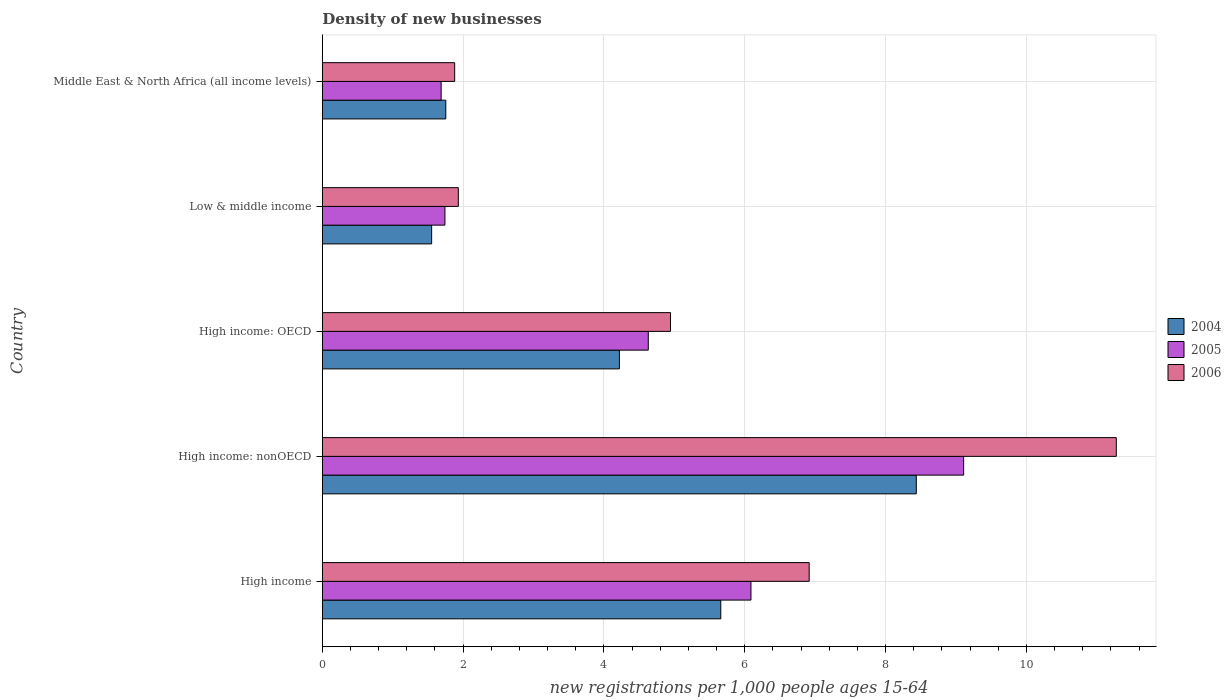How many different coloured bars are there?
Provide a short and direct response. 3. How many groups of bars are there?
Keep it short and to the point. 5. Are the number of bars per tick equal to the number of legend labels?
Your response must be concise. Yes. How many bars are there on the 1st tick from the bottom?
Your response must be concise. 3. What is the label of the 4th group of bars from the top?
Give a very brief answer. High income: nonOECD. In how many cases, is the number of bars for a given country not equal to the number of legend labels?
Keep it short and to the point. 0. What is the number of new registrations in 2005 in Low & middle income?
Make the answer very short. 1.74. Across all countries, what is the maximum number of new registrations in 2005?
Offer a terse response. 9.11. Across all countries, what is the minimum number of new registrations in 2005?
Provide a short and direct response. 1.69. In which country was the number of new registrations in 2005 maximum?
Keep it short and to the point. High income: nonOECD. In which country was the number of new registrations in 2005 minimum?
Provide a succinct answer. Middle East & North Africa (all income levels). What is the total number of new registrations in 2004 in the graph?
Offer a terse response. 21.62. What is the difference between the number of new registrations in 2005 in High income and that in High income: nonOECD?
Provide a succinct answer. -3.02. What is the difference between the number of new registrations in 2005 in Low & middle income and the number of new registrations in 2006 in Middle East & North Africa (all income levels)?
Provide a succinct answer. -0.14. What is the average number of new registrations in 2005 per country?
Offer a very short reply. 4.65. What is the difference between the number of new registrations in 2005 and number of new registrations in 2004 in Middle East & North Africa (all income levels)?
Keep it short and to the point. -0.07. What is the ratio of the number of new registrations in 2004 in High income to that in High income: nonOECD?
Ensure brevity in your answer.  0.67. Is the number of new registrations in 2005 in High income: nonOECD less than that in Low & middle income?
Make the answer very short. No. Is the difference between the number of new registrations in 2005 in Low & middle income and Middle East & North Africa (all income levels) greater than the difference between the number of new registrations in 2004 in Low & middle income and Middle East & North Africa (all income levels)?
Your response must be concise. Yes. What is the difference between the highest and the second highest number of new registrations in 2005?
Provide a succinct answer. 3.02. What is the difference between the highest and the lowest number of new registrations in 2004?
Keep it short and to the point. 6.88. In how many countries, is the number of new registrations in 2006 greater than the average number of new registrations in 2006 taken over all countries?
Offer a terse response. 2. Is the sum of the number of new registrations in 2005 in High income and Low & middle income greater than the maximum number of new registrations in 2006 across all countries?
Make the answer very short. No. What does the 3rd bar from the bottom in Middle East & North Africa (all income levels) represents?
Your response must be concise. 2006. Is it the case that in every country, the sum of the number of new registrations in 2006 and number of new registrations in 2004 is greater than the number of new registrations in 2005?
Give a very brief answer. Yes. What is the difference between two consecutive major ticks on the X-axis?
Provide a short and direct response. 2. Are the values on the major ticks of X-axis written in scientific E-notation?
Your response must be concise. No. Where does the legend appear in the graph?
Your response must be concise. Center right. How many legend labels are there?
Make the answer very short. 3. How are the legend labels stacked?
Ensure brevity in your answer.  Vertical. What is the title of the graph?
Ensure brevity in your answer.  Density of new businesses. Does "2012" appear as one of the legend labels in the graph?
Give a very brief answer. No. What is the label or title of the X-axis?
Your answer should be compact. New registrations per 1,0 people ages 15-64. What is the label or title of the Y-axis?
Provide a succinct answer. Country. What is the new registrations per 1,000 people ages 15-64 of 2004 in High income?
Make the answer very short. 5.66. What is the new registrations per 1,000 people ages 15-64 of 2005 in High income?
Offer a terse response. 6.09. What is the new registrations per 1,000 people ages 15-64 in 2006 in High income?
Provide a succinct answer. 6.91. What is the new registrations per 1,000 people ages 15-64 in 2004 in High income: nonOECD?
Offer a very short reply. 8.44. What is the new registrations per 1,000 people ages 15-64 of 2005 in High income: nonOECD?
Your response must be concise. 9.11. What is the new registrations per 1,000 people ages 15-64 of 2006 in High income: nonOECD?
Make the answer very short. 11.28. What is the new registrations per 1,000 people ages 15-64 in 2004 in High income: OECD?
Your answer should be very brief. 4.22. What is the new registrations per 1,000 people ages 15-64 of 2005 in High income: OECD?
Make the answer very short. 4.63. What is the new registrations per 1,000 people ages 15-64 of 2006 in High income: OECD?
Give a very brief answer. 4.94. What is the new registrations per 1,000 people ages 15-64 in 2004 in Low & middle income?
Give a very brief answer. 1.55. What is the new registrations per 1,000 people ages 15-64 in 2005 in Low & middle income?
Provide a succinct answer. 1.74. What is the new registrations per 1,000 people ages 15-64 in 2006 in Low & middle income?
Offer a very short reply. 1.93. What is the new registrations per 1,000 people ages 15-64 of 2004 in Middle East & North Africa (all income levels)?
Provide a succinct answer. 1.75. What is the new registrations per 1,000 people ages 15-64 in 2005 in Middle East & North Africa (all income levels)?
Make the answer very short. 1.69. What is the new registrations per 1,000 people ages 15-64 of 2006 in Middle East & North Africa (all income levels)?
Provide a short and direct response. 1.88. Across all countries, what is the maximum new registrations per 1,000 people ages 15-64 of 2004?
Your answer should be compact. 8.44. Across all countries, what is the maximum new registrations per 1,000 people ages 15-64 of 2005?
Provide a succinct answer. 9.11. Across all countries, what is the maximum new registrations per 1,000 people ages 15-64 in 2006?
Provide a succinct answer. 11.28. Across all countries, what is the minimum new registrations per 1,000 people ages 15-64 of 2004?
Your answer should be very brief. 1.55. Across all countries, what is the minimum new registrations per 1,000 people ages 15-64 in 2005?
Your response must be concise. 1.69. Across all countries, what is the minimum new registrations per 1,000 people ages 15-64 in 2006?
Give a very brief answer. 1.88. What is the total new registrations per 1,000 people ages 15-64 of 2004 in the graph?
Provide a short and direct response. 21.62. What is the total new registrations per 1,000 people ages 15-64 of 2005 in the graph?
Ensure brevity in your answer.  23.25. What is the total new registrations per 1,000 people ages 15-64 of 2006 in the graph?
Make the answer very short. 26.95. What is the difference between the new registrations per 1,000 people ages 15-64 of 2004 in High income and that in High income: nonOECD?
Provide a short and direct response. -2.78. What is the difference between the new registrations per 1,000 people ages 15-64 in 2005 in High income and that in High income: nonOECD?
Offer a very short reply. -3.02. What is the difference between the new registrations per 1,000 people ages 15-64 in 2006 in High income and that in High income: nonOECD?
Keep it short and to the point. -4.36. What is the difference between the new registrations per 1,000 people ages 15-64 in 2004 in High income and that in High income: OECD?
Offer a very short reply. 1.44. What is the difference between the new registrations per 1,000 people ages 15-64 of 2005 in High income and that in High income: OECD?
Your answer should be very brief. 1.46. What is the difference between the new registrations per 1,000 people ages 15-64 in 2006 in High income and that in High income: OECD?
Offer a terse response. 1.97. What is the difference between the new registrations per 1,000 people ages 15-64 in 2004 in High income and that in Low & middle income?
Your response must be concise. 4.11. What is the difference between the new registrations per 1,000 people ages 15-64 in 2005 in High income and that in Low & middle income?
Provide a short and direct response. 4.35. What is the difference between the new registrations per 1,000 people ages 15-64 in 2006 in High income and that in Low & middle income?
Offer a very short reply. 4.98. What is the difference between the new registrations per 1,000 people ages 15-64 in 2004 in High income and that in Middle East & North Africa (all income levels)?
Give a very brief answer. 3.91. What is the difference between the new registrations per 1,000 people ages 15-64 in 2005 in High income and that in Middle East & North Africa (all income levels)?
Keep it short and to the point. 4.4. What is the difference between the new registrations per 1,000 people ages 15-64 in 2006 in High income and that in Middle East & North Africa (all income levels)?
Provide a succinct answer. 5.04. What is the difference between the new registrations per 1,000 people ages 15-64 in 2004 in High income: nonOECD and that in High income: OECD?
Provide a short and direct response. 4.22. What is the difference between the new registrations per 1,000 people ages 15-64 of 2005 in High income: nonOECD and that in High income: OECD?
Ensure brevity in your answer.  4.48. What is the difference between the new registrations per 1,000 people ages 15-64 in 2006 in High income: nonOECD and that in High income: OECD?
Ensure brevity in your answer.  6.33. What is the difference between the new registrations per 1,000 people ages 15-64 of 2004 in High income: nonOECD and that in Low & middle income?
Offer a terse response. 6.88. What is the difference between the new registrations per 1,000 people ages 15-64 in 2005 in High income: nonOECD and that in Low & middle income?
Your answer should be very brief. 7.37. What is the difference between the new registrations per 1,000 people ages 15-64 in 2006 in High income: nonOECD and that in Low & middle income?
Your response must be concise. 9.34. What is the difference between the new registrations per 1,000 people ages 15-64 of 2004 in High income: nonOECD and that in Middle East & North Africa (all income levels)?
Keep it short and to the point. 6.68. What is the difference between the new registrations per 1,000 people ages 15-64 in 2005 in High income: nonOECD and that in Middle East & North Africa (all income levels)?
Your response must be concise. 7.42. What is the difference between the new registrations per 1,000 people ages 15-64 of 2006 in High income: nonOECD and that in Middle East & North Africa (all income levels)?
Your response must be concise. 9.4. What is the difference between the new registrations per 1,000 people ages 15-64 of 2004 in High income: OECD and that in Low & middle income?
Provide a short and direct response. 2.67. What is the difference between the new registrations per 1,000 people ages 15-64 in 2005 in High income: OECD and that in Low & middle income?
Keep it short and to the point. 2.89. What is the difference between the new registrations per 1,000 people ages 15-64 of 2006 in High income: OECD and that in Low & middle income?
Your answer should be compact. 3.01. What is the difference between the new registrations per 1,000 people ages 15-64 of 2004 in High income: OECD and that in Middle East & North Africa (all income levels)?
Provide a succinct answer. 2.47. What is the difference between the new registrations per 1,000 people ages 15-64 in 2005 in High income: OECD and that in Middle East & North Africa (all income levels)?
Offer a terse response. 2.94. What is the difference between the new registrations per 1,000 people ages 15-64 of 2006 in High income: OECD and that in Middle East & North Africa (all income levels)?
Provide a succinct answer. 3.07. What is the difference between the new registrations per 1,000 people ages 15-64 in 2004 in Low & middle income and that in Middle East & North Africa (all income levels)?
Your answer should be compact. -0.2. What is the difference between the new registrations per 1,000 people ages 15-64 in 2005 in Low & middle income and that in Middle East & North Africa (all income levels)?
Offer a terse response. 0.05. What is the difference between the new registrations per 1,000 people ages 15-64 of 2006 in Low & middle income and that in Middle East & North Africa (all income levels)?
Your response must be concise. 0.05. What is the difference between the new registrations per 1,000 people ages 15-64 in 2004 in High income and the new registrations per 1,000 people ages 15-64 in 2005 in High income: nonOECD?
Your response must be concise. -3.45. What is the difference between the new registrations per 1,000 people ages 15-64 of 2004 in High income and the new registrations per 1,000 people ages 15-64 of 2006 in High income: nonOECD?
Provide a succinct answer. -5.62. What is the difference between the new registrations per 1,000 people ages 15-64 in 2005 in High income and the new registrations per 1,000 people ages 15-64 in 2006 in High income: nonOECD?
Your response must be concise. -5.19. What is the difference between the new registrations per 1,000 people ages 15-64 in 2004 in High income and the new registrations per 1,000 people ages 15-64 in 2005 in High income: OECD?
Your response must be concise. 1.03. What is the difference between the new registrations per 1,000 people ages 15-64 of 2004 in High income and the new registrations per 1,000 people ages 15-64 of 2006 in High income: OECD?
Provide a short and direct response. 0.71. What is the difference between the new registrations per 1,000 people ages 15-64 of 2005 in High income and the new registrations per 1,000 people ages 15-64 of 2006 in High income: OECD?
Provide a short and direct response. 1.14. What is the difference between the new registrations per 1,000 people ages 15-64 in 2004 in High income and the new registrations per 1,000 people ages 15-64 in 2005 in Low & middle income?
Provide a short and direct response. 3.92. What is the difference between the new registrations per 1,000 people ages 15-64 of 2004 in High income and the new registrations per 1,000 people ages 15-64 of 2006 in Low & middle income?
Ensure brevity in your answer.  3.73. What is the difference between the new registrations per 1,000 people ages 15-64 of 2005 in High income and the new registrations per 1,000 people ages 15-64 of 2006 in Low & middle income?
Your answer should be compact. 4.16. What is the difference between the new registrations per 1,000 people ages 15-64 in 2004 in High income and the new registrations per 1,000 people ages 15-64 in 2005 in Middle East & North Africa (all income levels)?
Make the answer very short. 3.97. What is the difference between the new registrations per 1,000 people ages 15-64 in 2004 in High income and the new registrations per 1,000 people ages 15-64 in 2006 in Middle East & North Africa (all income levels)?
Your response must be concise. 3.78. What is the difference between the new registrations per 1,000 people ages 15-64 in 2005 in High income and the new registrations per 1,000 people ages 15-64 in 2006 in Middle East & North Africa (all income levels)?
Your answer should be very brief. 4.21. What is the difference between the new registrations per 1,000 people ages 15-64 of 2004 in High income: nonOECD and the new registrations per 1,000 people ages 15-64 of 2005 in High income: OECD?
Ensure brevity in your answer.  3.81. What is the difference between the new registrations per 1,000 people ages 15-64 in 2004 in High income: nonOECD and the new registrations per 1,000 people ages 15-64 in 2006 in High income: OECD?
Keep it short and to the point. 3.49. What is the difference between the new registrations per 1,000 people ages 15-64 in 2005 in High income: nonOECD and the new registrations per 1,000 people ages 15-64 in 2006 in High income: OECD?
Ensure brevity in your answer.  4.16. What is the difference between the new registrations per 1,000 people ages 15-64 in 2004 in High income: nonOECD and the new registrations per 1,000 people ages 15-64 in 2005 in Low & middle income?
Provide a succinct answer. 6.69. What is the difference between the new registrations per 1,000 people ages 15-64 in 2004 in High income: nonOECD and the new registrations per 1,000 people ages 15-64 in 2006 in Low & middle income?
Ensure brevity in your answer.  6.5. What is the difference between the new registrations per 1,000 people ages 15-64 in 2005 in High income: nonOECD and the new registrations per 1,000 people ages 15-64 in 2006 in Low & middle income?
Give a very brief answer. 7.18. What is the difference between the new registrations per 1,000 people ages 15-64 in 2004 in High income: nonOECD and the new registrations per 1,000 people ages 15-64 in 2005 in Middle East & North Africa (all income levels)?
Offer a terse response. 6.75. What is the difference between the new registrations per 1,000 people ages 15-64 in 2004 in High income: nonOECD and the new registrations per 1,000 people ages 15-64 in 2006 in Middle East & North Africa (all income levels)?
Offer a very short reply. 6.56. What is the difference between the new registrations per 1,000 people ages 15-64 of 2005 in High income: nonOECD and the new registrations per 1,000 people ages 15-64 of 2006 in Middle East & North Africa (all income levels)?
Ensure brevity in your answer.  7.23. What is the difference between the new registrations per 1,000 people ages 15-64 of 2004 in High income: OECD and the new registrations per 1,000 people ages 15-64 of 2005 in Low & middle income?
Provide a succinct answer. 2.48. What is the difference between the new registrations per 1,000 people ages 15-64 in 2004 in High income: OECD and the new registrations per 1,000 people ages 15-64 in 2006 in Low & middle income?
Your response must be concise. 2.29. What is the difference between the new registrations per 1,000 people ages 15-64 in 2005 in High income: OECD and the new registrations per 1,000 people ages 15-64 in 2006 in Low & middle income?
Provide a short and direct response. 2.7. What is the difference between the new registrations per 1,000 people ages 15-64 of 2004 in High income: OECD and the new registrations per 1,000 people ages 15-64 of 2005 in Middle East & North Africa (all income levels)?
Ensure brevity in your answer.  2.53. What is the difference between the new registrations per 1,000 people ages 15-64 in 2004 in High income: OECD and the new registrations per 1,000 people ages 15-64 in 2006 in Middle East & North Africa (all income levels)?
Keep it short and to the point. 2.34. What is the difference between the new registrations per 1,000 people ages 15-64 of 2005 in High income: OECD and the new registrations per 1,000 people ages 15-64 of 2006 in Middle East & North Africa (all income levels)?
Provide a succinct answer. 2.75. What is the difference between the new registrations per 1,000 people ages 15-64 in 2004 in Low & middle income and the new registrations per 1,000 people ages 15-64 in 2005 in Middle East & North Africa (all income levels)?
Provide a short and direct response. -0.13. What is the difference between the new registrations per 1,000 people ages 15-64 in 2004 in Low & middle income and the new registrations per 1,000 people ages 15-64 in 2006 in Middle East & North Africa (all income levels)?
Give a very brief answer. -0.33. What is the difference between the new registrations per 1,000 people ages 15-64 of 2005 in Low & middle income and the new registrations per 1,000 people ages 15-64 of 2006 in Middle East & North Africa (all income levels)?
Make the answer very short. -0.14. What is the average new registrations per 1,000 people ages 15-64 of 2004 per country?
Ensure brevity in your answer.  4.32. What is the average new registrations per 1,000 people ages 15-64 of 2005 per country?
Your answer should be compact. 4.65. What is the average new registrations per 1,000 people ages 15-64 in 2006 per country?
Provide a succinct answer. 5.39. What is the difference between the new registrations per 1,000 people ages 15-64 of 2004 and new registrations per 1,000 people ages 15-64 of 2005 in High income?
Make the answer very short. -0.43. What is the difference between the new registrations per 1,000 people ages 15-64 in 2004 and new registrations per 1,000 people ages 15-64 in 2006 in High income?
Your response must be concise. -1.26. What is the difference between the new registrations per 1,000 people ages 15-64 of 2005 and new registrations per 1,000 people ages 15-64 of 2006 in High income?
Give a very brief answer. -0.83. What is the difference between the new registrations per 1,000 people ages 15-64 of 2004 and new registrations per 1,000 people ages 15-64 of 2005 in High income: nonOECD?
Provide a succinct answer. -0.67. What is the difference between the new registrations per 1,000 people ages 15-64 in 2004 and new registrations per 1,000 people ages 15-64 in 2006 in High income: nonOECD?
Offer a terse response. -2.84. What is the difference between the new registrations per 1,000 people ages 15-64 in 2005 and new registrations per 1,000 people ages 15-64 in 2006 in High income: nonOECD?
Keep it short and to the point. -2.17. What is the difference between the new registrations per 1,000 people ages 15-64 in 2004 and new registrations per 1,000 people ages 15-64 in 2005 in High income: OECD?
Your answer should be compact. -0.41. What is the difference between the new registrations per 1,000 people ages 15-64 in 2004 and new registrations per 1,000 people ages 15-64 in 2006 in High income: OECD?
Your response must be concise. -0.73. What is the difference between the new registrations per 1,000 people ages 15-64 in 2005 and new registrations per 1,000 people ages 15-64 in 2006 in High income: OECD?
Offer a terse response. -0.32. What is the difference between the new registrations per 1,000 people ages 15-64 in 2004 and new registrations per 1,000 people ages 15-64 in 2005 in Low & middle income?
Offer a terse response. -0.19. What is the difference between the new registrations per 1,000 people ages 15-64 of 2004 and new registrations per 1,000 people ages 15-64 of 2006 in Low & middle income?
Offer a terse response. -0.38. What is the difference between the new registrations per 1,000 people ages 15-64 in 2005 and new registrations per 1,000 people ages 15-64 in 2006 in Low & middle income?
Your response must be concise. -0.19. What is the difference between the new registrations per 1,000 people ages 15-64 in 2004 and new registrations per 1,000 people ages 15-64 in 2005 in Middle East & North Africa (all income levels)?
Give a very brief answer. 0.07. What is the difference between the new registrations per 1,000 people ages 15-64 in 2004 and new registrations per 1,000 people ages 15-64 in 2006 in Middle East & North Africa (all income levels)?
Keep it short and to the point. -0.13. What is the difference between the new registrations per 1,000 people ages 15-64 of 2005 and new registrations per 1,000 people ages 15-64 of 2006 in Middle East & North Africa (all income levels)?
Give a very brief answer. -0.19. What is the ratio of the new registrations per 1,000 people ages 15-64 in 2004 in High income to that in High income: nonOECD?
Provide a short and direct response. 0.67. What is the ratio of the new registrations per 1,000 people ages 15-64 of 2005 in High income to that in High income: nonOECD?
Your answer should be very brief. 0.67. What is the ratio of the new registrations per 1,000 people ages 15-64 in 2006 in High income to that in High income: nonOECD?
Provide a short and direct response. 0.61. What is the ratio of the new registrations per 1,000 people ages 15-64 in 2004 in High income to that in High income: OECD?
Provide a succinct answer. 1.34. What is the ratio of the new registrations per 1,000 people ages 15-64 in 2005 in High income to that in High income: OECD?
Provide a succinct answer. 1.31. What is the ratio of the new registrations per 1,000 people ages 15-64 in 2006 in High income to that in High income: OECD?
Keep it short and to the point. 1.4. What is the ratio of the new registrations per 1,000 people ages 15-64 in 2004 in High income to that in Low & middle income?
Give a very brief answer. 3.64. What is the ratio of the new registrations per 1,000 people ages 15-64 of 2005 in High income to that in Low & middle income?
Make the answer very short. 3.5. What is the ratio of the new registrations per 1,000 people ages 15-64 of 2006 in High income to that in Low & middle income?
Ensure brevity in your answer.  3.58. What is the ratio of the new registrations per 1,000 people ages 15-64 in 2004 in High income to that in Middle East & North Africa (all income levels)?
Your answer should be very brief. 3.23. What is the ratio of the new registrations per 1,000 people ages 15-64 in 2005 in High income to that in Middle East & North Africa (all income levels)?
Your answer should be very brief. 3.61. What is the ratio of the new registrations per 1,000 people ages 15-64 of 2006 in High income to that in Middle East & North Africa (all income levels)?
Ensure brevity in your answer.  3.68. What is the ratio of the new registrations per 1,000 people ages 15-64 of 2004 in High income: nonOECD to that in High income: OECD?
Offer a terse response. 2. What is the ratio of the new registrations per 1,000 people ages 15-64 in 2005 in High income: nonOECD to that in High income: OECD?
Your answer should be very brief. 1.97. What is the ratio of the new registrations per 1,000 people ages 15-64 in 2006 in High income: nonOECD to that in High income: OECD?
Provide a succinct answer. 2.28. What is the ratio of the new registrations per 1,000 people ages 15-64 of 2004 in High income: nonOECD to that in Low & middle income?
Make the answer very short. 5.43. What is the ratio of the new registrations per 1,000 people ages 15-64 of 2005 in High income: nonOECD to that in Low & middle income?
Keep it short and to the point. 5.23. What is the ratio of the new registrations per 1,000 people ages 15-64 of 2006 in High income: nonOECD to that in Low & middle income?
Your answer should be compact. 5.84. What is the ratio of the new registrations per 1,000 people ages 15-64 in 2004 in High income: nonOECD to that in Middle East & North Africa (all income levels)?
Keep it short and to the point. 4.81. What is the ratio of the new registrations per 1,000 people ages 15-64 of 2005 in High income: nonOECD to that in Middle East & North Africa (all income levels)?
Your response must be concise. 5.4. What is the ratio of the new registrations per 1,000 people ages 15-64 in 2006 in High income: nonOECD to that in Middle East & North Africa (all income levels)?
Your answer should be compact. 6. What is the ratio of the new registrations per 1,000 people ages 15-64 in 2004 in High income: OECD to that in Low & middle income?
Ensure brevity in your answer.  2.72. What is the ratio of the new registrations per 1,000 people ages 15-64 in 2005 in High income: OECD to that in Low & middle income?
Ensure brevity in your answer.  2.66. What is the ratio of the new registrations per 1,000 people ages 15-64 in 2006 in High income: OECD to that in Low & middle income?
Your answer should be very brief. 2.56. What is the ratio of the new registrations per 1,000 people ages 15-64 of 2004 in High income: OECD to that in Middle East & North Africa (all income levels)?
Offer a terse response. 2.41. What is the ratio of the new registrations per 1,000 people ages 15-64 of 2005 in High income: OECD to that in Middle East & North Africa (all income levels)?
Make the answer very short. 2.74. What is the ratio of the new registrations per 1,000 people ages 15-64 in 2006 in High income: OECD to that in Middle East & North Africa (all income levels)?
Provide a short and direct response. 2.63. What is the ratio of the new registrations per 1,000 people ages 15-64 in 2004 in Low & middle income to that in Middle East & North Africa (all income levels)?
Your response must be concise. 0.89. What is the ratio of the new registrations per 1,000 people ages 15-64 of 2005 in Low & middle income to that in Middle East & North Africa (all income levels)?
Ensure brevity in your answer.  1.03. What is the ratio of the new registrations per 1,000 people ages 15-64 of 2006 in Low & middle income to that in Middle East & North Africa (all income levels)?
Your response must be concise. 1.03. What is the difference between the highest and the second highest new registrations per 1,000 people ages 15-64 in 2004?
Provide a succinct answer. 2.78. What is the difference between the highest and the second highest new registrations per 1,000 people ages 15-64 of 2005?
Offer a terse response. 3.02. What is the difference between the highest and the second highest new registrations per 1,000 people ages 15-64 of 2006?
Provide a succinct answer. 4.36. What is the difference between the highest and the lowest new registrations per 1,000 people ages 15-64 in 2004?
Keep it short and to the point. 6.88. What is the difference between the highest and the lowest new registrations per 1,000 people ages 15-64 of 2005?
Make the answer very short. 7.42. What is the difference between the highest and the lowest new registrations per 1,000 people ages 15-64 in 2006?
Offer a very short reply. 9.4. 